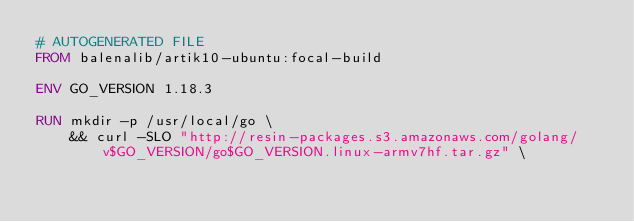<code> <loc_0><loc_0><loc_500><loc_500><_Dockerfile_># AUTOGENERATED FILE
FROM balenalib/artik10-ubuntu:focal-build

ENV GO_VERSION 1.18.3

RUN mkdir -p /usr/local/go \
	&& curl -SLO "http://resin-packages.s3.amazonaws.com/golang/v$GO_VERSION/go$GO_VERSION.linux-armv7hf.tar.gz" \</code> 